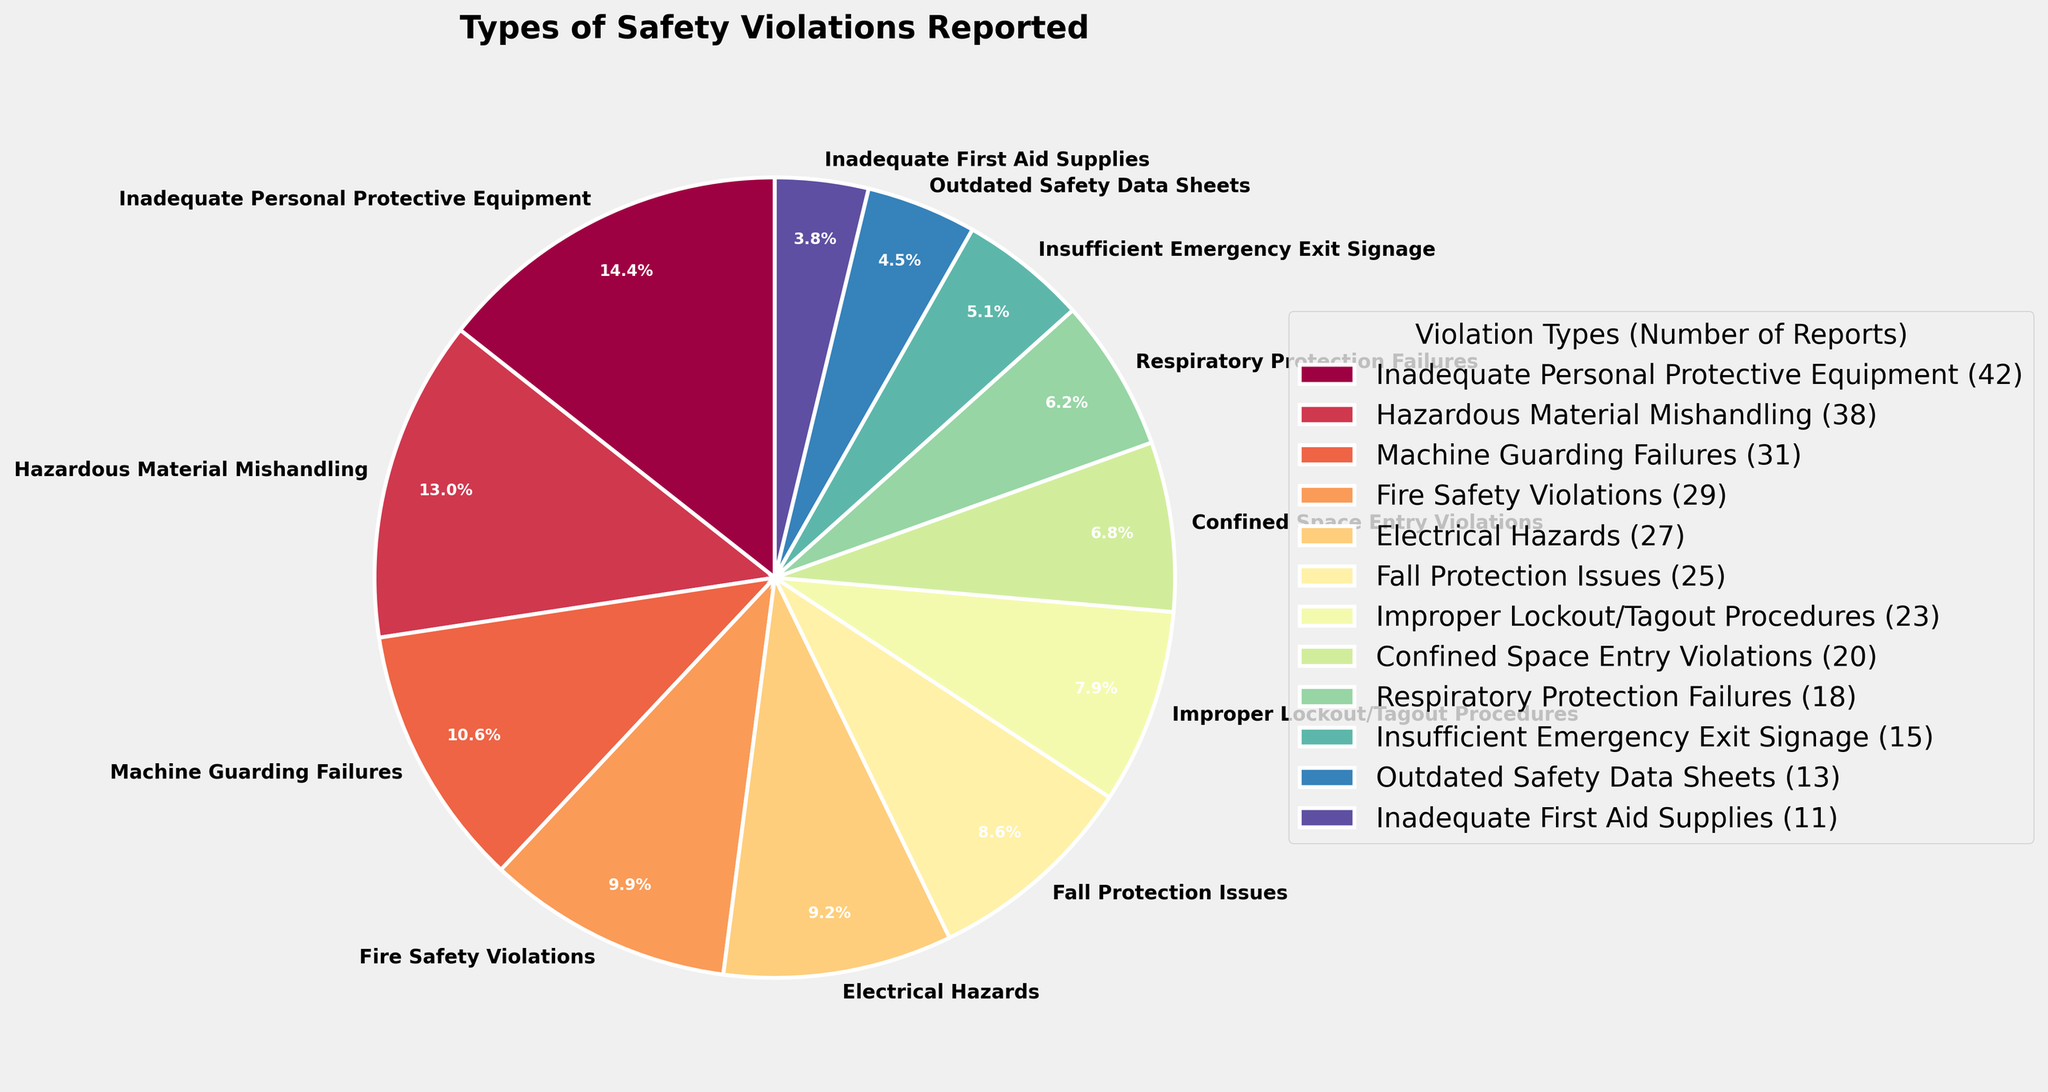What percentage of safety violations are related to "Inadequate Personal Protective Equipment"? First, locate the segment labeled "Inadequate Personal Protective Equipment" on the pie chart. Then, read the corresponding percentage value displayed on the chart. This percentage represents the portion of safety violations for this type of violation.
Answer: 15.22% Which safety violation type has the second highest number of reports? Review the chart and identify the segment with the second largest percentage label. Then, match the segment’s label to the violation type. The one with the largest segment represents the highest number of reports, and the second largest segment represents the second highest.
Answer: Hazardous Material Mishandling How many more reports are there for "Fire Safety Violations" compared to "Inadequate First Aid Supplies"? Identify the number of reports for both "Fire Safety Violations" and "Inadequate First Aid Supplies" from the legend or chart labels. Subtract the latter’s number from the former’s. Fire Safety Violations have 29 reports, and Inadequate First Aid Supplies have 11 reports. The difference is 29 - 11.
Answer: 18 What is the total number of reports classified as "Moderate"? Sum the number of reports for all "Moderate" violations: "Improper Lockout/Tagout Procedures" (23), "Confined Space Entry Violations" (20), and "Respiratory Protection Failures" (18). 23 + 20 + 18 equals 61.
Answer: 61 Which violation type has the smallest number of reports, and what is the number? Locate the segment or legend item with the smallest percentage or size and identify the corresponding violation type and its number of reports.
Answer: Inadequate First Aid Supplies, 11 Which three violation types are categorized as "Critical"? Refer to the legend or segment labels to identify which violation types are marked as "Critical." Typically, the critical ones could be color-coded similarly. Identify the three attributes that fit this severity category.
Answer: Inadequate Personal Protective Equipment, Hazardous Material Mishandling, Machine Guarding Failures What is the combined percentage of "Low" severity violation types? Add the percentage values displayed on the chart for all "Low" severity violation types: "Insufficient Emergency Exit Signage," "Outdated Safety Data Sheets," and "Inadequate First Aid Supplies." Since percentages are not given directly in the data provided, they will be calculated based on their segment sizes. For simplification, take note that these contribute a small combined portion of the pie chart, summing up to a noticeable minority value.
Answer: Approx 20% How many violation types have more than 25 reports? Identify and count segments in the pie chart or legend labels that show more than 25 reports.
Answer: 3 What color represents "Electrical Hazards" in the chart? Identify the segment labeled "Electrical Hazards" and describe the corresponding color used visually.
Answer: Red (or similar distinctive color based on the given color map used for the chart) How does the number of "Machine Guarding Failures" compare to "Fall Protection Issues"? Compare the number of reports for "Machine Guarding Failures" (31 reports) with those of "Fall Protection Issues" (25 reports) by direct numerical comparison.
Answer: Machine Guarding Failures have 6 more reports 